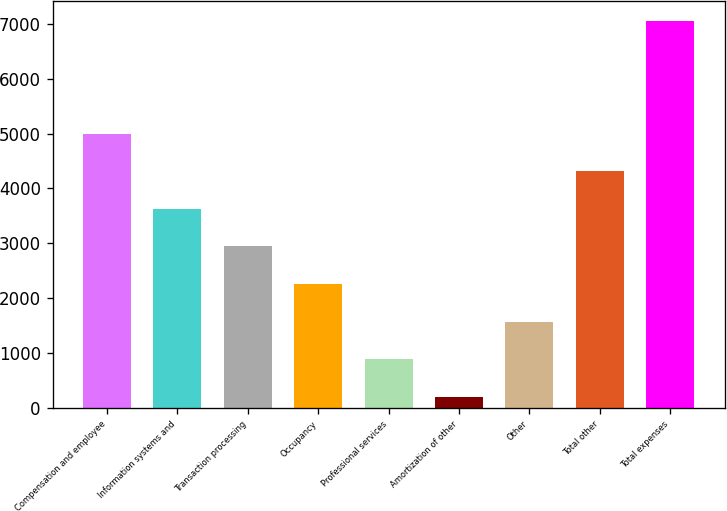Convert chart. <chart><loc_0><loc_0><loc_500><loc_500><bar_chart><fcel>Compensation and employee<fcel>Information systems and<fcel>Transaction processing<fcel>Occupancy<fcel>Professional services<fcel>Amortization of other<fcel>Other<fcel>Total other<fcel>Total expenses<nl><fcel>5000.6<fcel>3629<fcel>2943.2<fcel>2257.4<fcel>885.8<fcel>200<fcel>1571.6<fcel>4314.8<fcel>7058<nl></chart> 